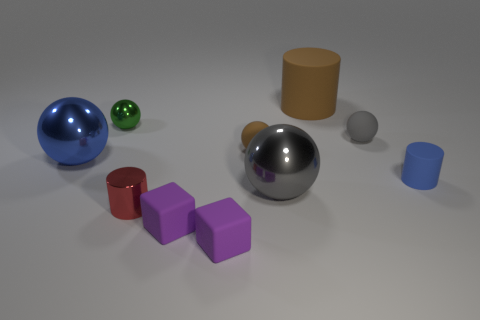Is there a brown matte ball that has the same size as the gray rubber ball?
Give a very brief answer. Yes. Does the small red object have the same material as the large ball that is in front of the blue metal ball?
Provide a succinct answer. Yes. What is the material of the sphere left of the green shiny sphere?
Make the answer very short. Metal. What size is the red shiny cylinder?
Provide a succinct answer. Small. There is a brown matte thing that is to the left of the gray shiny sphere; does it have the same size as the gray object on the left side of the brown rubber cylinder?
Provide a short and direct response. No. What size is the brown rubber thing that is the same shape as the green thing?
Keep it short and to the point. Small. There is a green ball; is its size the same as the ball on the left side of the tiny green thing?
Make the answer very short. No. There is a brown object that is in front of the tiny green ball; are there any purple things that are on the left side of it?
Your answer should be compact. Yes. What shape is the blue object right of the brown cylinder?
Keep it short and to the point. Cylinder. What material is the tiny ball that is the same color as the large cylinder?
Your answer should be compact. Rubber. 